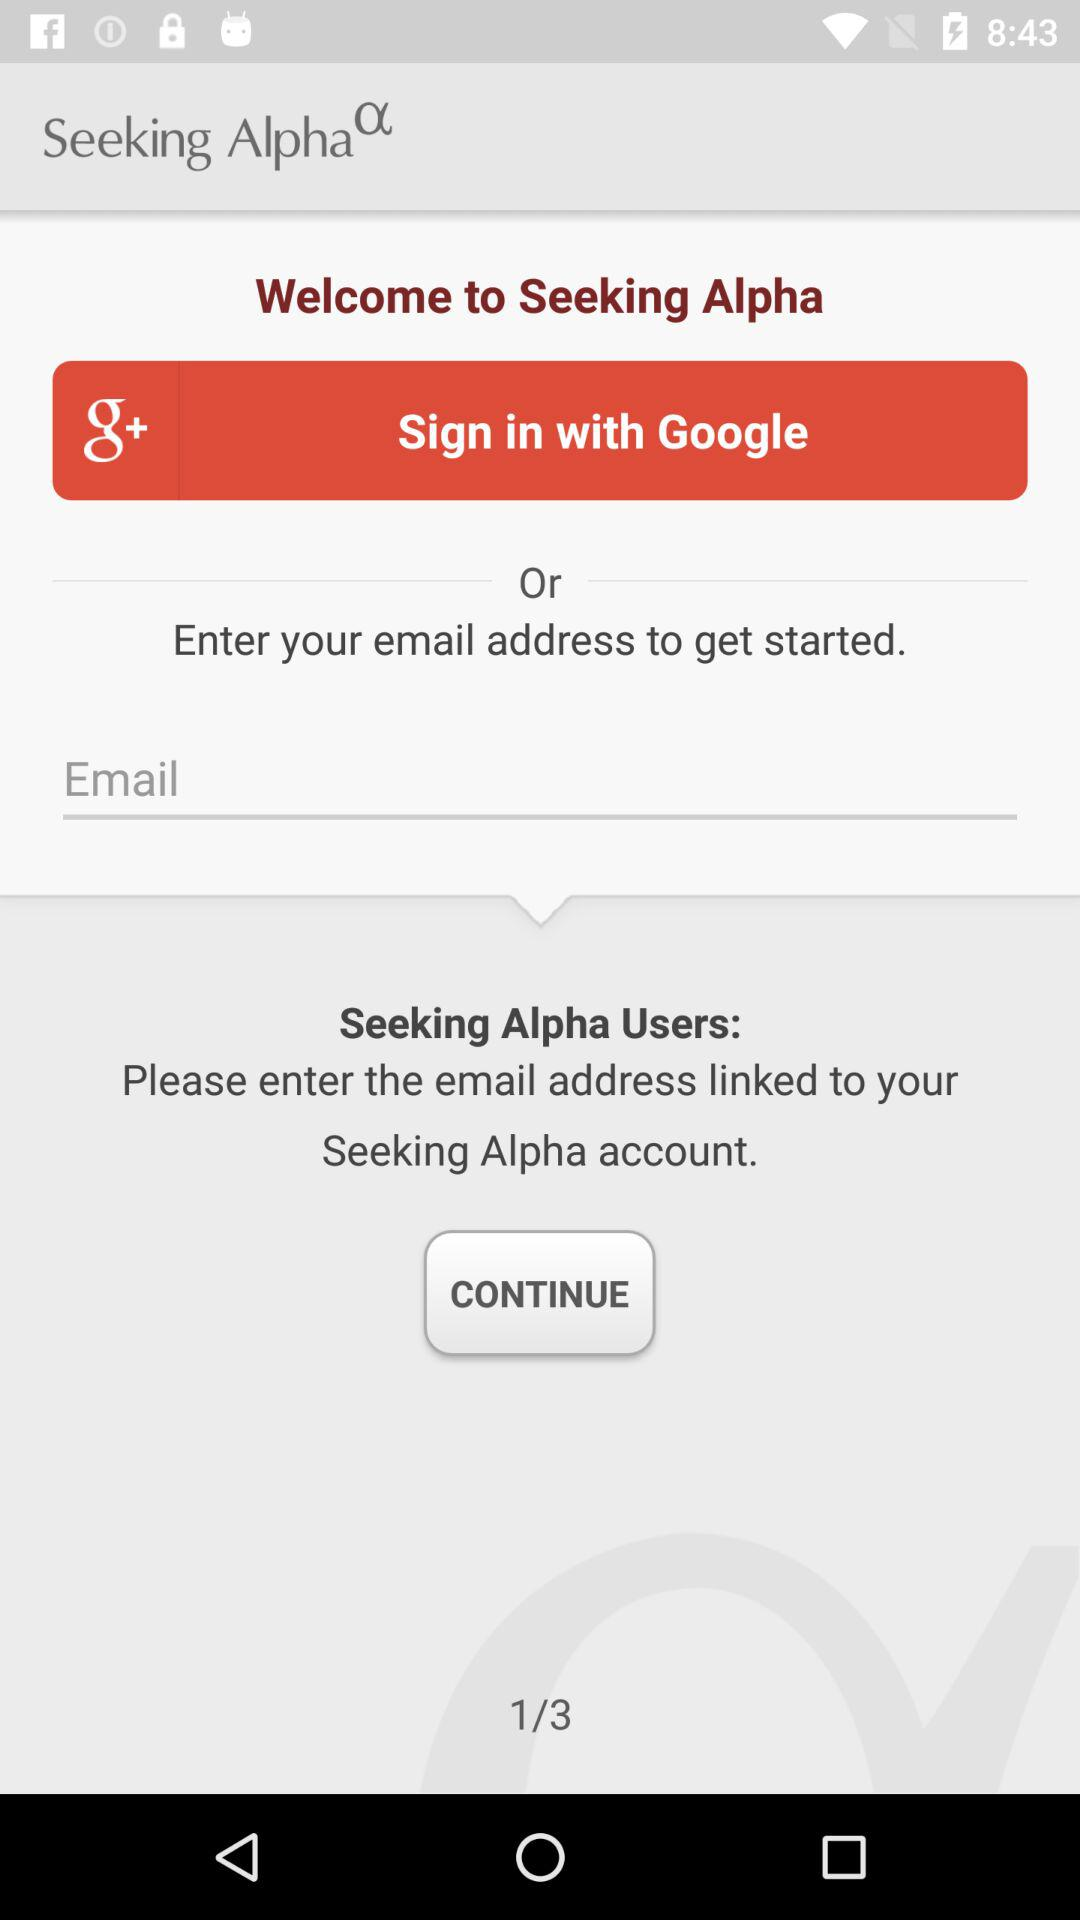What is the application name? The application name is "Seeking Alpha". 